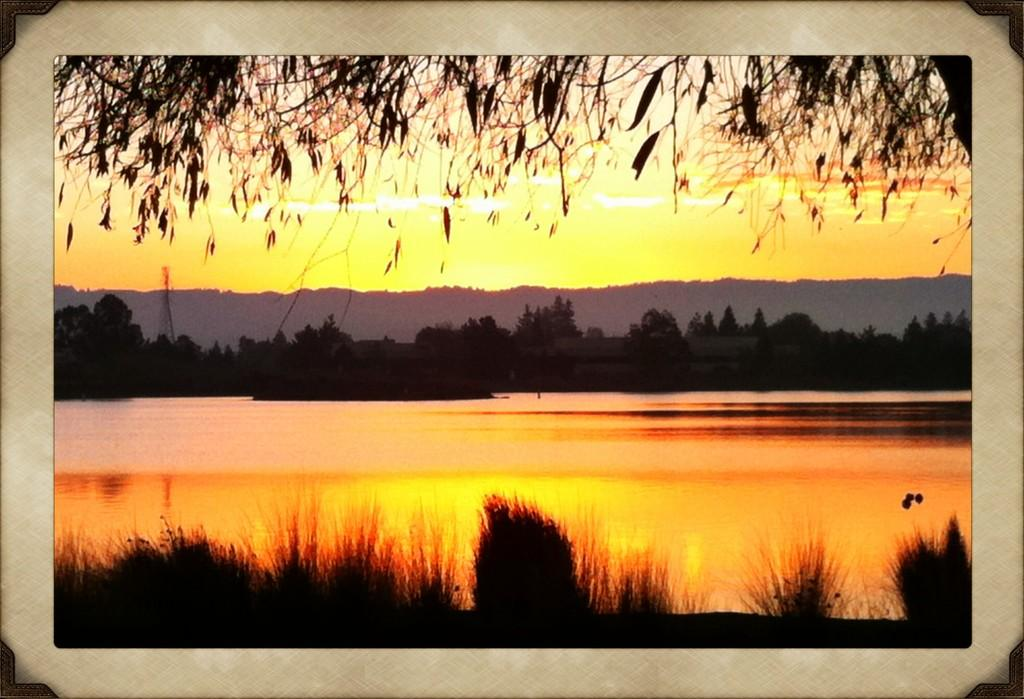What type of natural elements can be seen in the image? There are trees, water, and mountains visible in the image. What is visible in the background of the image? The sky is visible in the background of the image. What can be observed in the sky? Clouds are present in the sky. What type of government is depicted in the image? There is no government depicted in the image; it features natural elements such as trees, water, mountains, sky, and clouds. 